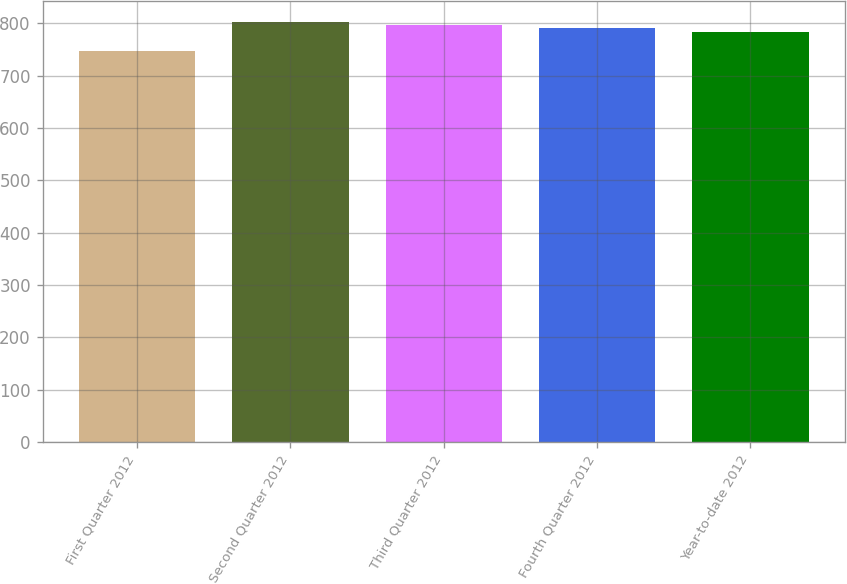Convert chart. <chart><loc_0><loc_0><loc_500><loc_500><bar_chart><fcel>First Quarter 2012<fcel>Second Quarter 2012<fcel>Third Quarter 2012<fcel>Fourth Quarter 2012<fcel>Year-to-date 2012<nl><fcel>747<fcel>802.3<fcel>797<fcel>791<fcel>784<nl></chart> 